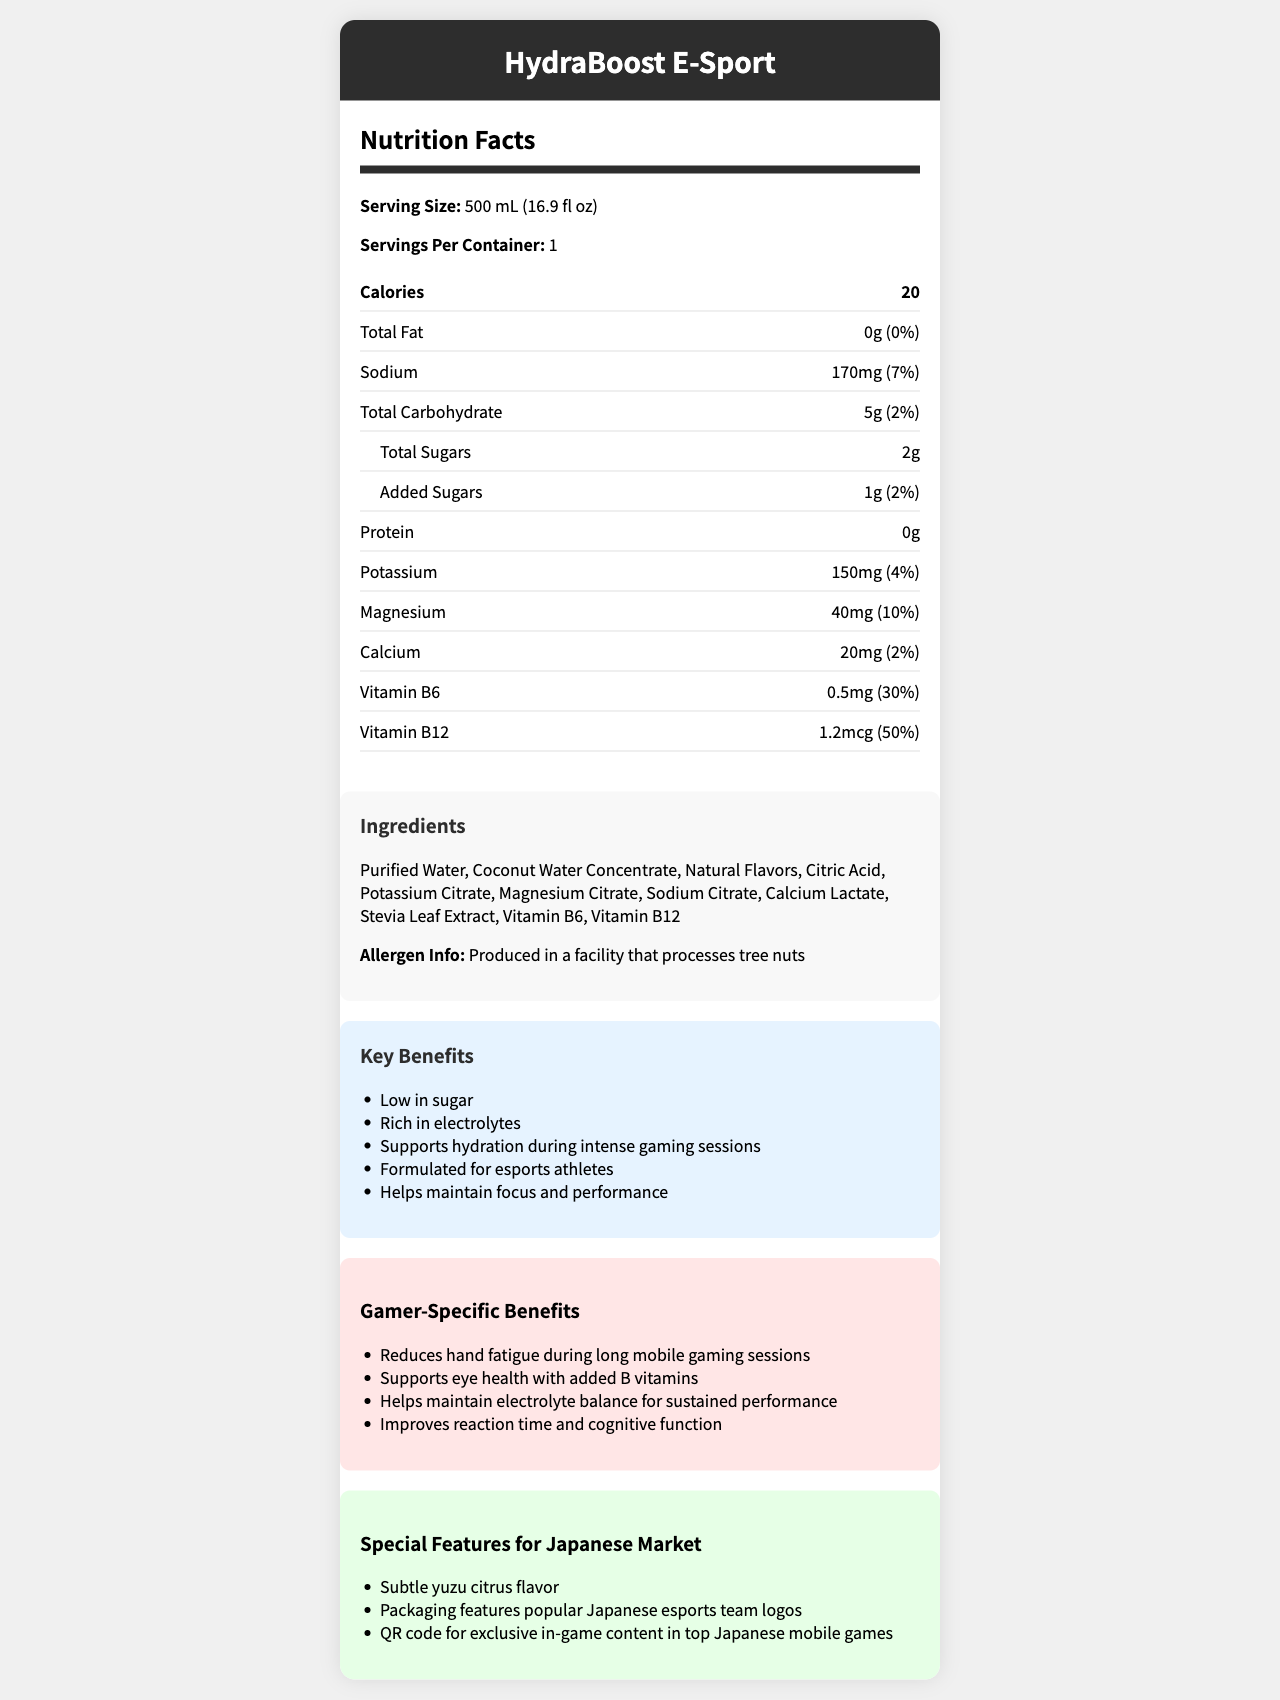what is the serving size of the HydraBoost E-Sport? The serving size is mentioned at the beginning of the Nutrition Facts section as "Serving Size: 500 mL (16.9 fl oz)".
Answer: 500 mL (16.9 fl oz) how many calories are there per serving? The document clearly states "Calories: 20" in the Nutrition Facts section.
Answer: 20 what percentage of daily value is sodium in one serving? The document lists Sodium content as "170mg (7%)" in the Nutrition Facts section.
Answer: 7% how much protein is in the beverage? The document mentions "Protein: 0g" in the Nutrition Facts section.
Answer: 0g which vitamins are included in the beverage? The Nutrition Facts section lists "Vitamin B6" and "Vitamin B12" with their respective amounts and daily values.
Answer: Vitamin B6 and Vitamin B12 what are the main ingredients in HydraBoost E-Sport? The Ingredients section of the document lists all the ingredients used, starting with Purified Water, Coconut Water Concentrate, and so on.
Answer: Purified Water, Coconut Water Concentrate, Natural Flavors, Citric Acid, etc. which of the following is NOT a key benefit mentioned? A. Improves bone strength B. Supports hydration during intense gaming sessions C. Helps maintain focus and performance The key benefits listed include "Supports hydration during intense gaming sessions" and "Helps maintain focus and performance"; improving bone strength is not mentioned.
Answer: A. Improves bone strength how much potassium does one serving contain? The Nutrition Facts section states Potassium content as "150mg (4%)".
Answer: 150mg is this beverage gluten-free? The document provides allergen information related to tree nuts, but it does not mention gluten.
Answer: Not enough information which specific benefit is aimed at reducing hand fatigue? A. Improves reaction time B. Reduces hand fatigue during long mobile gaming sessions C. Supports eye health The Gamer-Specific Benefits section lists “Reduces hand fatigue during long mobile gaming sessions” as a benefit.
Answer: B. Reduces hand fatigue during long mobile gaming sessions does HydraBoost E-Sport provide more Vitamin B6 or Vitamin B12? The Nutrition Facts section shows that Vitamin B6 is 0.5mg (30% DV) and Vitamin B12 is 1.2mcg (50% DV), indicating a higher daily value percentage of Vitamin B12.
Answer: Vitamin B12 are there any added sugars in HydraBoost E-Sport? The Nutrition Facts section includes Added Sugars with an amount of "1g (2%)".
Answer: Yes summarize the main idea of this document. The document provides comprehensive nutrition facts, lists ingredients, allergen information, marketing claims, gamer-specific benefits, and special features for the Japanese market.
Answer: HydraBoost E-Sport is a low-sugar, electrolyte-rich beverage formulated for esports athletes. It contains key electrolytes like sodium, potassium, magnesium, and calcium, and vitamins B6 and B12 to support hydration, focus, and performance during intense gaming sessions. what is the marketing claim related to focus and performance? The Marketing section lists "Helps maintain focus and performance" as one of the key benefits.
Answer: Helps maintain focus and performance is the beverage designed to support eye health? The Gamer-Specific Benefits section mentions "Supports eye health with added B vitamins".
Answer: Yes how many servings are there per container of HydraBoost E-Sport? The Nutrition Facts section mentions "Servings Per Container: 1".
Answer: 1 what is the flavor specifically mentioned for the Japanese market? The Special Features for Japanese Market section states "Subtle yuzu citrus flavor".
Answer: Subtle yuzu citrus flavor can you determine the manufacturing country from this document? The document does not provide any information regarding the manufacturing country.
Answer: No 